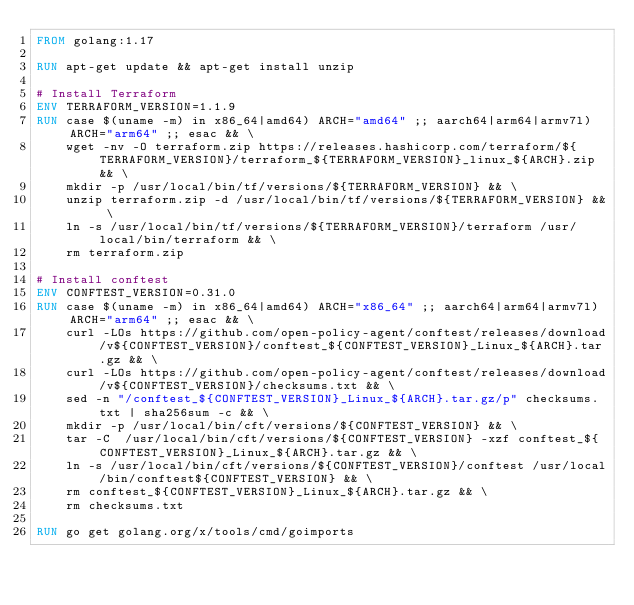Convert code to text. <code><loc_0><loc_0><loc_500><loc_500><_Dockerfile_>FROM golang:1.17

RUN apt-get update && apt-get install unzip

# Install Terraform
ENV TERRAFORM_VERSION=1.1.9
RUN case $(uname -m) in x86_64|amd64) ARCH="amd64" ;; aarch64|arm64|armv7l) ARCH="arm64" ;; esac && \
    wget -nv -O terraform.zip https://releases.hashicorp.com/terraform/${TERRAFORM_VERSION}/terraform_${TERRAFORM_VERSION}_linux_${ARCH}.zip && \
    mkdir -p /usr/local/bin/tf/versions/${TERRAFORM_VERSION} && \
    unzip terraform.zip -d /usr/local/bin/tf/versions/${TERRAFORM_VERSION} && \
    ln -s /usr/local/bin/tf/versions/${TERRAFORM_VERSION}/terraform /usr/local/bin/terraform && \
    rm terraform.zip

# Install conftest
ENV CONFTEST_VERSION=0.31.0
RUN case $(uname -m) in x86_64|amd64) ARCH="x86_64" ;; aarch64|arm64|armv7l) ARCH="arm64" ;; esac && \
    curl -LOs https://github.com/open-policy-agent/conftest/releases/download/v${CONFTEST_VERSION}/conftest_${CONFTEST_VERSION}_Linux_${ARCH}.tar.gz && \
    curl -LOs https://github.com/open-policy-agent/conftest/releases/download/v${CONFTEST_VERSION}/checksums.txt && \
    sed -n "/conftest_${CONFTEST_VERSION}_Linux_${ARCH}.tar.gz/p" checksums.txt | sha256sum -c && \
    mkdir -p /usr/local/bin/cft/versions/${CONFTEST_VERSION} && \
    tar -C  /usr/local/bin/cft/versions/${CONFTEST_VERSION} -xzf conftest_${CONFTEST_VERSION}_Linux_${ARCH}.tar.gz && \
    ln -s /usr/local/bin/cft/versions/${CONFTEST_VERSION}/conftest /usr/local/bin/conftest${CONFTEST_VERSION} && \
    rm conftest_${CONFTEST_VERSION}_Linux_${ARCH}.tar.gz && \
    rm checksums.txt

RUN go get golang.org/x/tools/cmd/goimports
</code> 